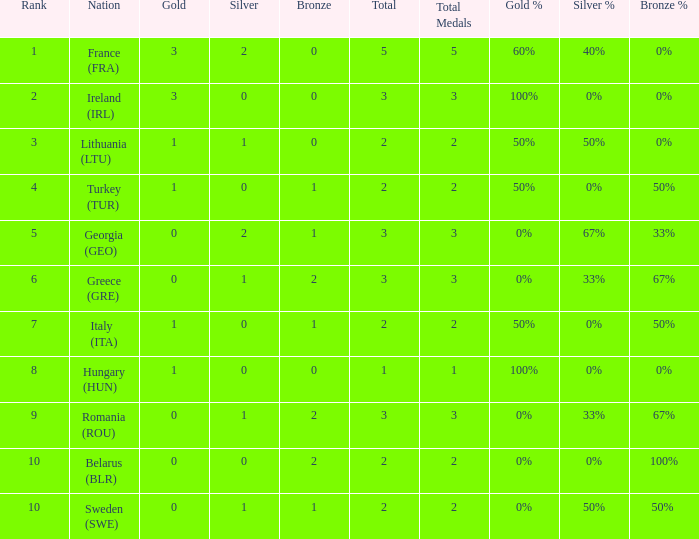What are the most bronze medals in a rank more than 1 with a total larger than 3? None. 